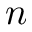Convert formula to latex. <formula><loc_0><loc_0><loc_500><loc_500>n</formula> 